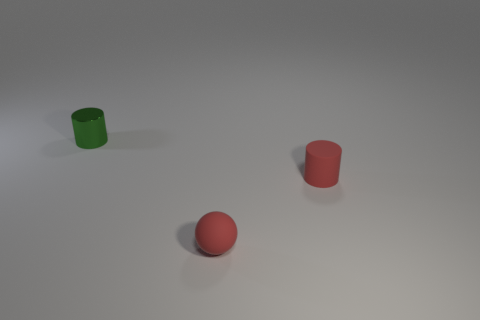How might the sizes of these objects compare to a common household item? Considering their relative size to each other and the general context, these objects could be compared to a standard mug or cup. The cylindrical shapes are similar in dimension to what you might find in a kitchen for holding beverages, and the ball is about the size of a small fruit, such as an apricot or a plum. 